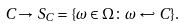Convert formula to latex. <formula><loc_0><loc_0><loc_500><loc_500>C \to S _ { C } = \{ \omega \in \Omega \colon \omega \hookleftarrow C \} .</formula> 